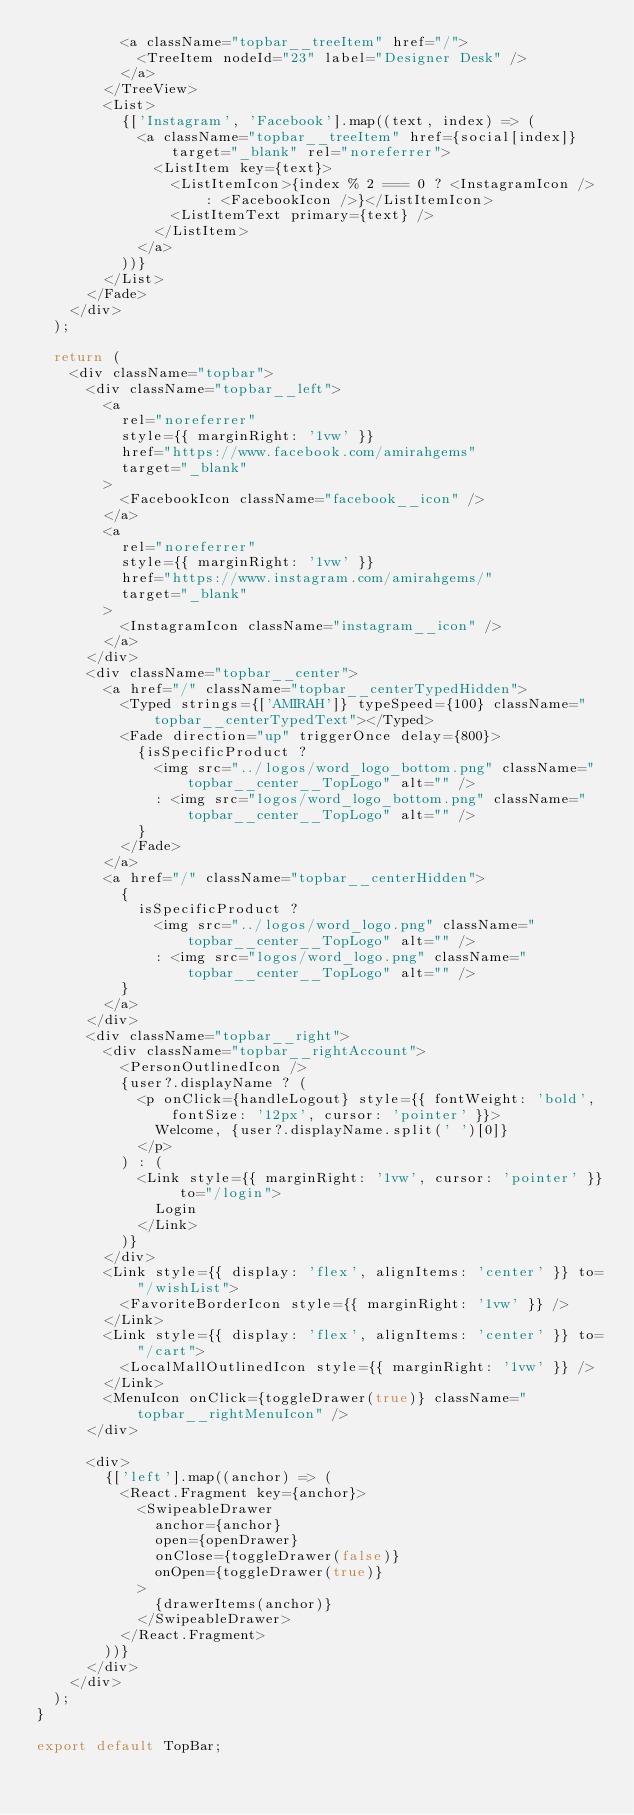<code> <loc_0><loc_0><loc_500><loc_500><_JavaScript_>					<a className="topbar__treeItem" href="/">
						<TreeItem nodeId="23" label="Designer Desk" />
					</a>
				</TreeView>
				<List>
					{['Instagram', 'Facebook'].map((text, index) => (
						<a className="topbar__treeItem" href={social[index]} target="_blank" rel="noreferrer">
							<ListItem key={text}>
								<ListItemIcon>{index % 2 === 0 ? <InstagramIcon /> : <FacebookIcon />}</ListItemIcon>
								<ListItemText primary={text} />
							</ListItem>
						</a>
					))}
				</List>
			</Fade>
		</div>
	);

	return (
		<div className="topbar">
			<div className="topbar__left">
				<a
					rel="noreferrer"
					style={{ marginRight: '1vw' }}
					href="https://www.facebook.com/amirahgems"
					target="_blank"
				>
					<FacebookIcon className="facebook__icon" />
				</a>
				<a
					rel="noreferrer"
					style={{ marginRight: '1vw' }}
					href="https://www.instagram.com/amirahgems/"
					target="_blank"
				>
					<InstagramIcon className="instagram__icon" />
				</a>
			</div>
			<div className="topbar__center">
				<a href="/" className="topbar__centerTypedHidden">
					<Typed strings={['AMIRAH']} typeSpeed={100} className="topbar__centerTypedText"></Typed>
					<Fade direction="up" triggerOnce delay={800}>
						{isSpecificProduct ?
							<img src="../logos/word_logo_bottom.png" className="topbar__center__TopLogo" alt="" />
							: <img src="logos/word_logo_bottom.png" className="topbar__center__TopLogo" alt="" />
						}
					</Fade>
				</a>
				<a href="/" className="topbar__centerHidden">
					{
						isSpecificProduct ?
							<img src="../logos/word_logo.png" className="topbar__center__TopLogo" alt="" />
							: <img src="logos/word_logo.png" className="topbar__center__TopLogo" alt="" />
					}
				</a>
			</div>
			<div className="topbar__right">
				<div className="topbar__rightAccount">
					<PersonOutlinedIcon />
					{user?.displayName ? (
						<p onClick={handleLogout} style={{ fontWeight: 'bold', fontSize: '12px', cursor: 'pointer' }}>
							Welcome, {user?.displayName.split(' ')[0]}
						</p>
					) : (
						<Link style={{ marginRight: '1vw', cursor: 'pointer' }} to="/login">
							Login
						</Link>
					)}
				</div>
				<Link style={{ display: 'flex', alignItems: 'center' }} to="/wishList">
					<FavoriteBorderIcon style={{ marginRight: '1vw' }} />
				</Link>
				<Link style={{ display: 'flex', alignItems: 'center' }} to="/cart">
					<LocalMallOutlinedIcon style={{ marginRight: '1vw' }} />
				</Link>
				<MenuIcon onClick={toggleDrawer(true)} className="topbar__rightMenuIcon" />
			</div>

			<div>
				{['left'].map((anchor) => (
					<React.Fragment key={anchor}>
						<SwipeableDrawer
							anchor={anchor}
							open={openDrawer}
							onClose={toggleDrawer(false)}
							onOpen={toggleDrawer(true)}
						>
							{drawerItems(anchor)}
						</SwipeableDrawer>
					</React.Fragment>
				))}
			</div>
		</div>
	);
}

export default TopBar;
</code> 